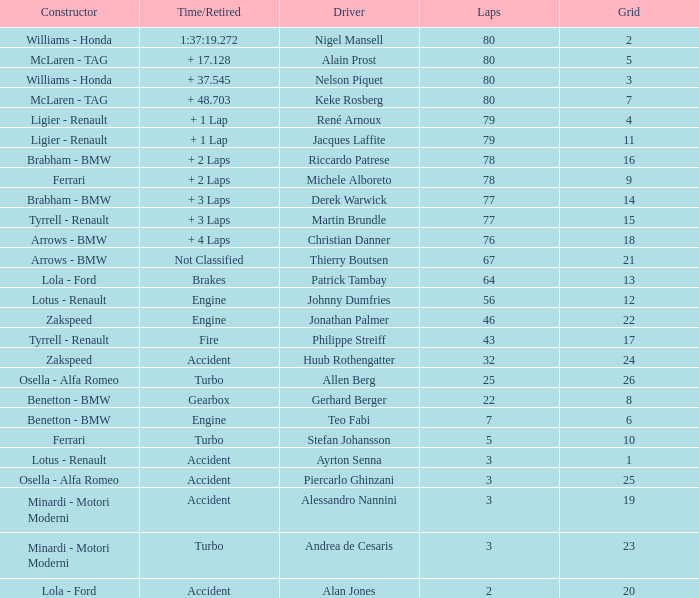What is the time/retired for thierry boutsen? Not Classified. 